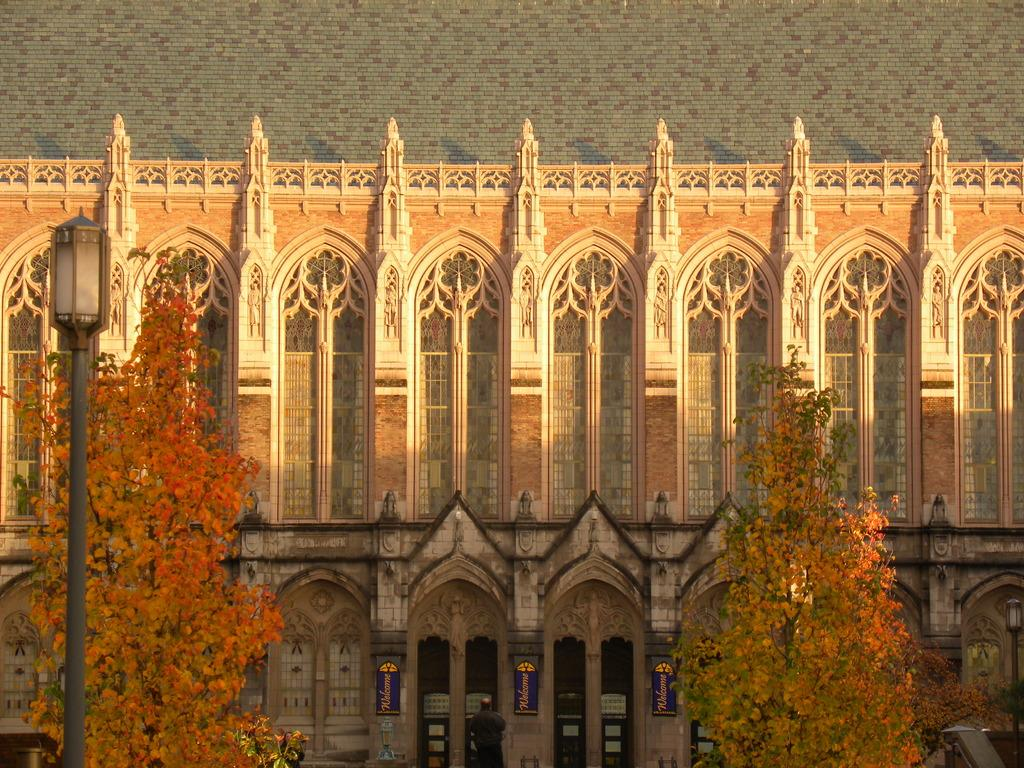What type of structure is present in the image? There is a building in the image. What feature of the building is mentioned in the facts? The building has many windows. What can be seen in front of the building? There are trees in front of the building. Where is the street light located in the image? The street light is on the left side of the image. What type of credit can be seen being offered to the beggar in the image? There is no beggar or credit present in the image. What type of beam is supporting the building in the image? The facts provided do not mention any specific type of beam supporting the building, so we cannot answer this question. 